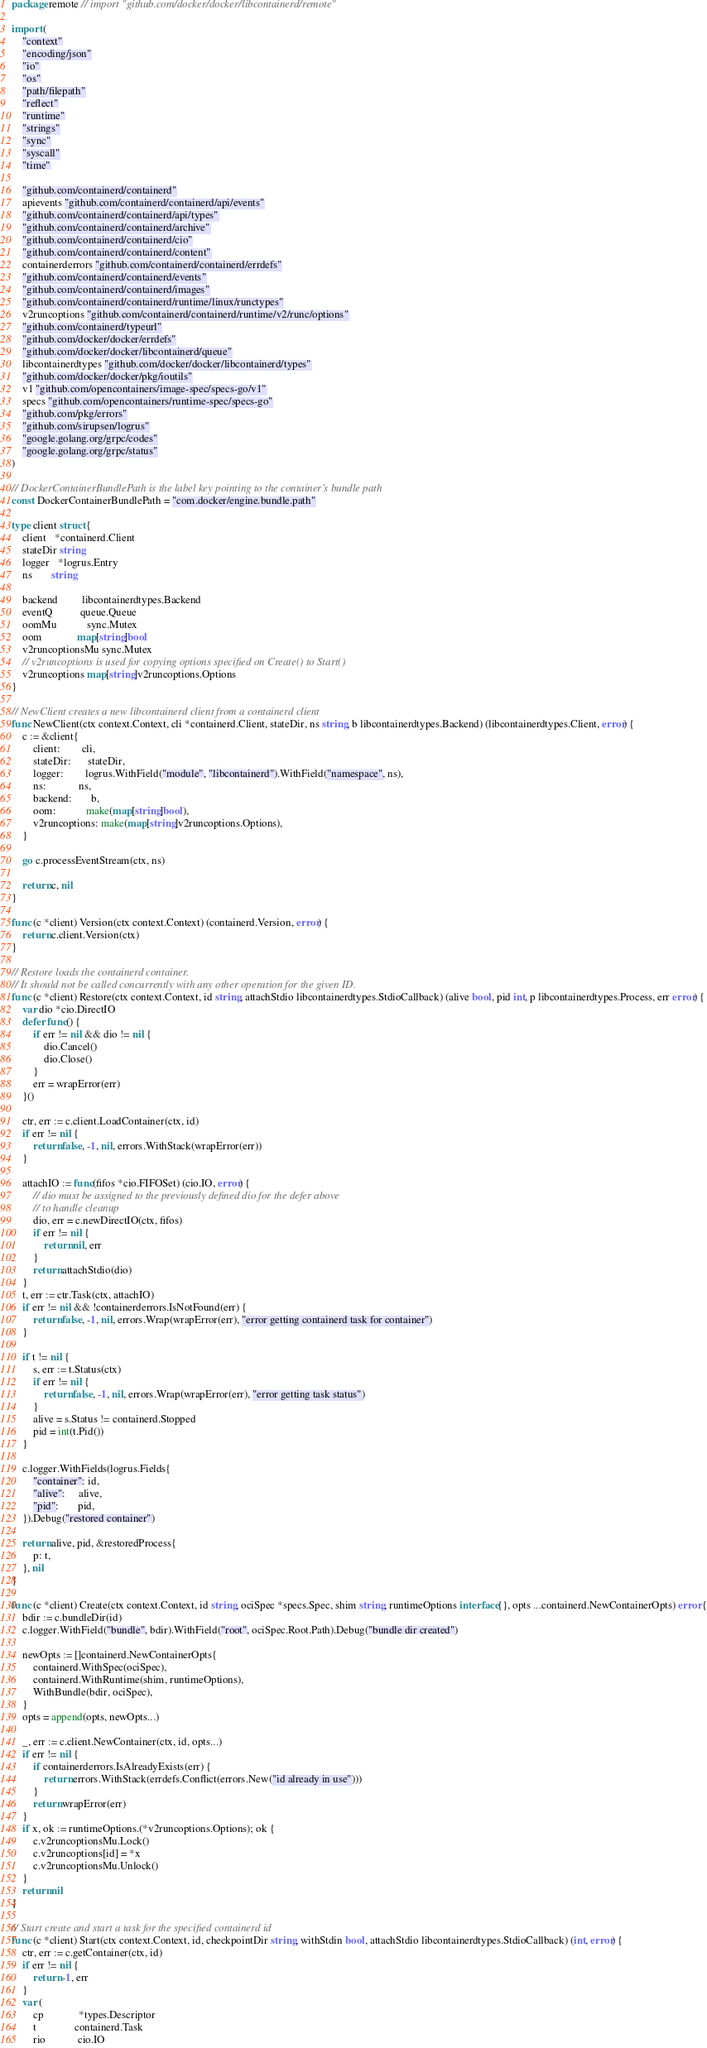Convert code to text. <code><loc_0><loc_0><loc_500><loc_500><_Go_>package remote // import "github.com/docker/docker/libcontainerd/remote"

import (
	"context"
	"encoding/json"
	"io"
	"os"
	"path/filepath"
	"reflect"
	"runtime"
	"strings"
	"sync"
	"syscall"
	"time"

	"github.com/containerd/containerd"
	apievents "github.com/containerd/containerd/api/events"
	"github.com/containerd/containerd/api/types"
	"github.com/containerd/containerd/archive"
	"github.com/containerd/containerd/cio"
	"github.com/containerd/containerd/content"
	containerderrors "github.com/containerd/containerd/errdefs"
	"github.com/containerd/containerd/events"
	"github.com/containerd/containerd/images"
	"github.com/containerd/containerd/runtime/linux/runctypes"
	v2runcoptions "github.com/containerd/containerd/runtime/v2/runc/options"
	"github.com/containerd/typeurl"
	"github.com/docker/docker/errdefs"
	"github.com/docker/docker/libcontainerd/queue"
	libcontainerdtypes "github.com/docker/docker/libcontainerd/types"
	"github.com/docker/docker/pkg/ioutils"
	v1 "github.com/opencontainers/image-spec/specs-go/v1"
	specs "github.com/opencontainers/runtime-spec/specs-go"
	"github.com/pkg/errors"
	"github.com/sirupsen/logrus"
	"google.golang.org/grpc/codes"
	"google.golang.org/grpc/status"
)

// DockerContainerBundlePath is the label key pointing to the container's bundle path
const DockerContainerBundlePath = "com.docker/engine.bundle.path"

type client struct {
	client   *containerd.Client
	stateDir string
	logger   *logrus.Entry
	ns       string

	backend         libcontainerdtypes.Backend
	eventQ          queue.Queue
	oomMu           sync.Mutex
	oom             map[string]bool
	v2runcoptionsMu sync.Mutex
	// v2runcoptions is used for copying options specified on Create() to Start()
	v2runcoptions map[string]v2runcoptions.Options
}

// NewClient creates a new libcontainerd client from a containerd client
func NewClient(ctx context.Context, cli *containerd.Client, stateDir, ns string, b libcontainerdtypes.Backend) (libcontainerdtypes.Client, error) {
	c := &client{
		client:        cli,
		stateDir:      stateDir,
		logger:        logrus.WithField("module", "libcontainerd").WithField("namespace", ns),
		ns:            ns,
		backend:       b,
		oom:           make(map[string]bool),
		v2runcoptions: make(map[string]v2runcoptions.Options),
	}

	go c.processEventStream(ctx, ns)

	return c, nil
}

func (c *client) Version(ctx context.Context) (containerd.Version, error) {
	return c.client.Version(ctx)
}

// Restore loads the containerd container.
// It should not be called concurrently with any other operation for the given ID.
func (c *client) Restore(ctx context.Context, id string, attachStdio libcontainerdtypes.StdioCallback) (alive bool, pid int, p libcontainerdtypes.Process, err error) {
	var dio *cio.DirectIO
	defer func() {
		if err != nil && dio != nil {
			dio.Cancel()
			dio.Close()
		}
		err = wrapError(err)
	}()

	ctr, err := c.client.LoadContainer(ctx, id)
	if err != nil {
		return false, -1, nil, errors.WithStack(wrapError(err))
	}

	attachIO := func(fifos *cio.FIFOSet) (cio.IO, error) {
		// dio must be assigned to the previously defined dio for the defer above
		// to handle cleanup
		dio, err = c.newDirectIO(ctx, fifos)
		if err != nil {
			return nil, err
		}
		return attachStdio(dio)
	}
	t, err := ctr.Task(ctx, attachIO)
	if err != nil && !containerderrors.IsNotFound(err) {
		return false, -1, nil, errors.Wrap(wrapError(err), "error getting containerd task for container")
	}

	if t != nil {
		s, err := t.Status(ctx)
		if err != nil {
			return false, -1, nil, errors.Wrap(wrapError(err), "error getting task status")
		}
		alive = s.Status != containerd.Stopped
		pid = int(t.Pid())
	}

	c.logger.WithFields(logrus.Fields{
		"container": id,
		"alive":     alive,
		"pid":       pid,
	}).Debug("restored container")

	return alive, pid, &restoredProcess{
		p: t,
	}, nil
}

func (c *client) Create(ctx context.Context, id string, ociSpec *specs.Spec, shim string, runtimeOptions interface{}, opts ...containerd.NewContainerOpts) error {
	bdir := c.bundleDir(id)
	c.logger.WithField("bundle", bdir).WithField("root", ociSpec.Root.Path).Debug("bundle dir created")

	newOpts := []containerd.NewContainerOpts{
		containerd.WithSpec(ociSpec),
		containerd.WithRuntime(shim, runtimeOptions),
		WithBundle(bdir, ociSpec),
	}
	opts = append(opts, newOpts...)

	_, err := c.client.NewContainer(ctx, id, opts...)
	if err != nil {
		if containerderrors.IsAlreadyExists(err) {
			return errors.WithStack(errdefs.Conflict(errors.New("id already in use")))
		}
		return wrapError(err)
	}
	if x, ok := runtimeOptions.(*v2runcoptions.Options); ok {
		c.v2runcoptionsMu.Lock()
		c.v2runcoptions[id] = *x
		c.v2runcoptionsMu.Unlock()
	}
	return nil
}

// Start create and start a task for the specified containerd id
func (c *client) Start(ctx context.Context, id, checkpointDir string, withStdin bool, attachStdio libcontainerdtypes.StdioCallback) (int, error) {
	ctr, err := c.getContainer(ctx, id)
	if err != nil {
		return -1, err
	}
	var (
		cp             *types.Descriptor
		t              containerd.Task
		rio            cio.IO</code> 